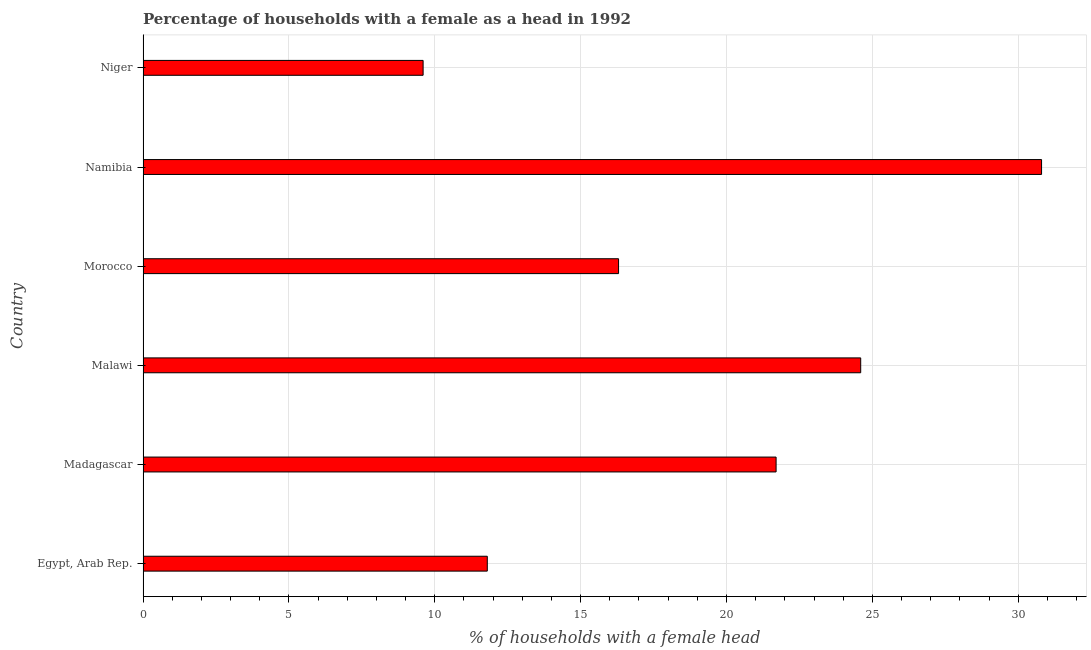Does the graph contain any zero values?
Keep it short and to the point. No. What is the title of the graph?
Offer a terse response. Percentage of households with a female as a head in 1992. What is the label or title of the X-axis?
Offer a terse response. % of households with a female head. What is the number of female supervised households in Madagascar?
Provide a short and direct response. 21.7. Across all countries, what is the maximum number of female supervised households?
Your response must be concise. 30.8. Across all countries, what is the minimum number of female supervised households?
Offer a terse response. 9.6. In which country was the number of female supervised households maximum?
Provide a short and direct response. Namibia. In which country was the number of female supervised households minimum?
Offer a very short reply. Niger. What is the sum of the number of female supervised households?
Your answer should be compact. 114.8. What is the difference between the number of female supervised households in Madagascar and Morocco?
Offer a terse response. 5.4. What is the average number of female supervised households per country?
Keep it short and to the point. 19.13. What is the median number of female supervised households?
Ensure brevity in your answer.  19. What is the ratio of the number of female supervised households in Egypt, Arab Rep. to that in Madagascar?
Provide a short and direct response. 0.54. Is the sum of the number of female supervised households in Egypt, Arab Rep. and Madagascar greater than the maximum number of female supervised households across all countries?
Provide a succinct answer. Yes. What is the difference between the highest and the lowest number of female supervised households?
Your response must be concise. 21.2. In how many countries, is the number of female supervised households greater than the average number of female supervised households taken over all countries?
Offer a terse response. 3. How many bars are there?
Give a very brief answer. 6. Are all the bars in the graph horizontal?
Ensure brevity in your answer.  Yes. How many countries are there in the graph?
Your answer should be very brief. 6. What is the % of households with a female head of Madagascar?
Give a very brief answer. 21.7. What is the % of households with a female head of Malawi?
Give a very brief answer. 24.6. What is the % of households with a female head in Morocco?
Make the answer very short. 16.3. What is the % of households with a female head in Namibia?
Make the answer very short. 30.8. What is the difference between the % of households with a female head in Egypt, Arab Rep. and Madagascar?
Your answer should be very brief. -9.9. What is the difference between the % of households with a female head in Egypt, Arab Rep. and Malawi?
Make the answer very short. -12.8. What is the difference between the % of households with a female head in Egypt, Arab Rep. and Namibia?
Offer a terse response. -19. What is the difference between the % of households with a female head in Madagascar and Malawi?
Your answer should be compact. -2.9. What is the difference between the % of households with a female head in Madagascar and Morocco?
Provide a short and direct response. 5.4. What is the difference between the % of households with a female head in Madagascar and Namibia?
Give a very brief answer. -9.1. What is the difference between the % of households with a female head in Madagascar and Niger?
Keep it short and to the point. 12.1. What is the difference between the % of households with a female head in Malawi and Morocco?
Ensure brevity in your answer.  8.3. What is the difference between the % of households with a female head in Malawi and Namibia?
Offer a very short reply. -6.2. What is the difference between the % of households with a female head in Malawi and Niger?
Ensure brevity in your answer.  15. What is the difference between the % of households with a female head in Morocco and Namibia?
Offer a very short reply. -14.5. What is the difference between the % of households with a female head in Morocco and Niger?
Make the answer very short. 6.7. What is the difference between the % of households with a female head in Namibia and Niger?
Provide a short and direct response. 21.2. What is the ratio of the % of households with a female head in Egypt, Arab Rep. to that in Madagascar?
Offer a terse response. 0.54. What is the ratio of the % of households with a female head in Egypt, Arab Rep. to that in Malawi?
Your answer should be compact. 0.48. What is the ratio of the % of households with a female head in Egypt, Arab Rep. to that in Morocco?
Provide a succinct answer. 0.72. What is the ratio of the % of households with a female head in Egypt, Arab Rep. to that in Namibia?
Provide a succinct answer. 0.38. What is the ratio of the % of households with a female head in Egypt, Arab Rep. to that in Niger?
Keep it short and to the point. 1.23. What is the ratio of the % of households with a female head in Madagascar to that in Malawi?
Offer a terse response. 0.88. What is the ratio of the % of households with a female head in Madagascar to that in Morocco?
Provide a short and direct response. 1.33. What is the ratio of the % of households with a female head in Madagascar to that in Namibia?
Provide a succinct answer. 0.7. What is the ratio of the % of households with a female head in Madagascar to that in Niger?
Ensure brevity in your answer.  2.26. What is the ratio of the % of households with a female head in Malawi to that in Morocco?
Offer a very short reply. 1.51. What is the ratio of the % of households with a female head in Malawi to that in Namibia?
Provide a short and direct response. 0.8. What is the ratio of the % of households with a female head in Malawi to that in Niger?
Give a very brief answer. 2.56. What is the ratio of the % of households with a female head in Morocco to that in Namibia?
Make the answer very short. 0.53. What is the ratio of the % of households with a female head in Morocco to that in Niger?
Offer a terse response. 1.7. What is the ratio of the % of households with a female head in Namibia to that in Niger?
Provide a succinct answer. 3.21. 